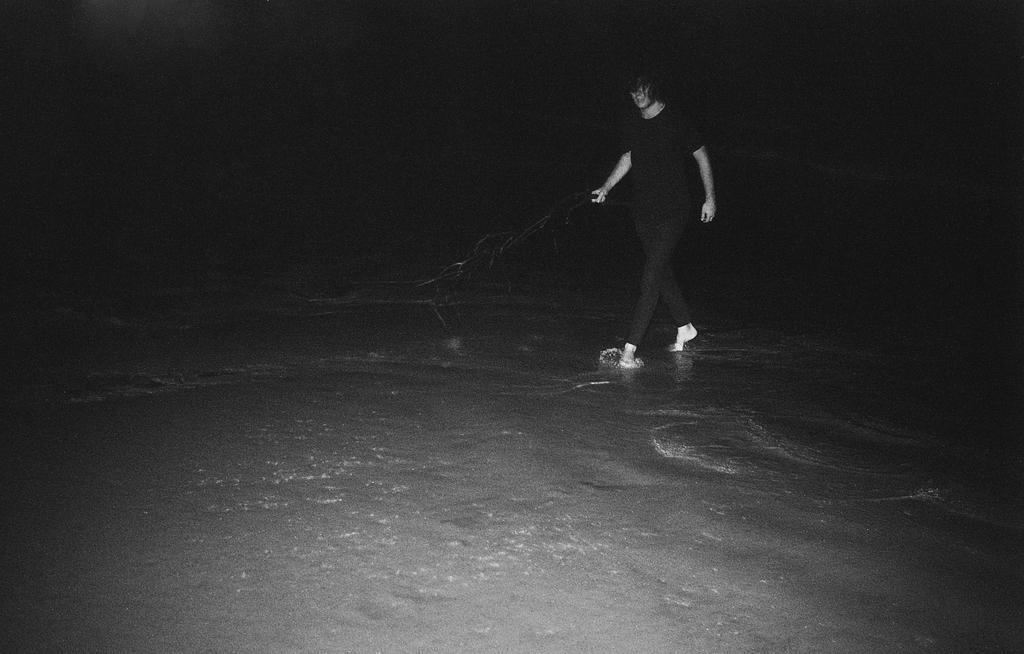Describe this image in one or two sentences. In this picture we see a woman standing on the sea shore in the dark. 